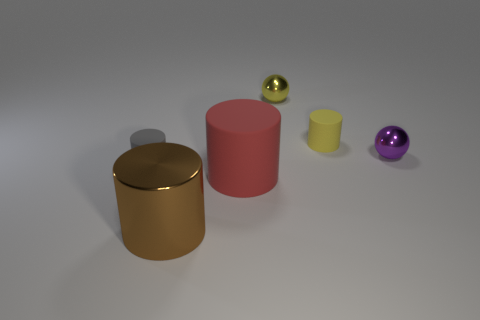Can you describe the lighting and shadows visible in the image? The image features a soft diffused lighting that casts gentle shadows to the right of the objects. This suggests that the primary light source is coming from the upper left. The shadows help provide a sense of depth and positional context for each object on the flat surface. 